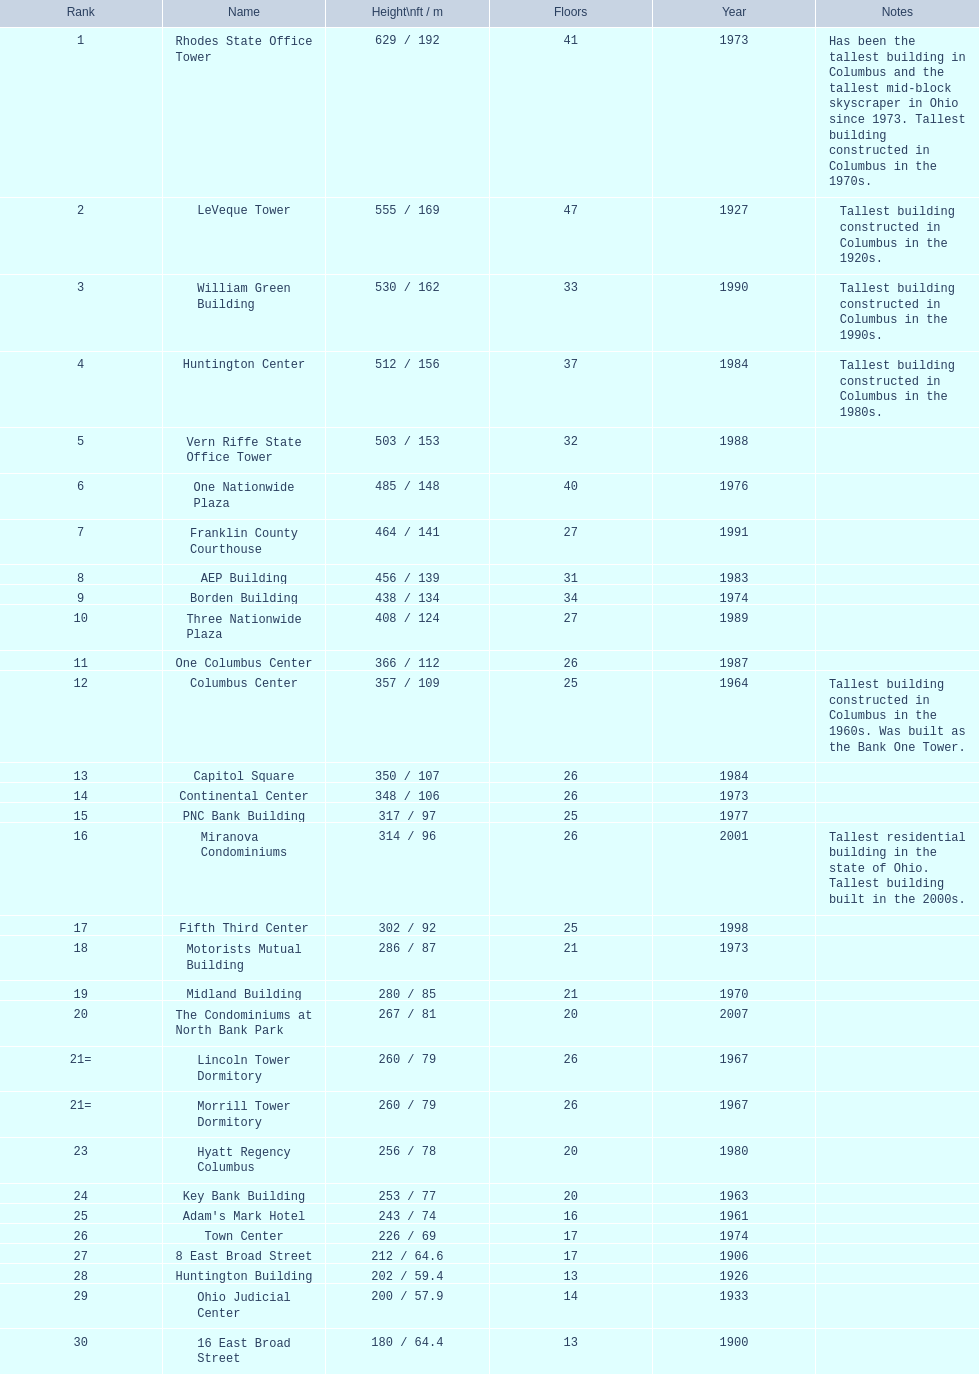Which of the highest structures in columbus, ohio were constructed in the 1980s? Huntington Center, Vern Riffe State Office Tower, AEP Building, Three Nationwide Plaza, One Columbus Center, Capitol Square, Hyatt Regency Columbus. Of these structures, which have between 26 and 31 stories? AEP Building, Three Nationwide Plaza, One Columbus Center, Capitol Square. Of these structures, which is the loftiest? AEP Building. 